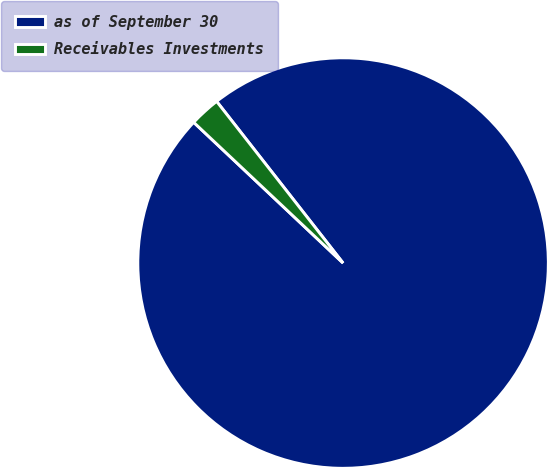Convert chart to OTSL. <chart><loc_0><loc_0><loc_500><loc_500><pie_chart><fcel>as of September 30<fcel>Receivables Investments<nl><fcel>97.59%<fcel>2.41%<nl></chart> 